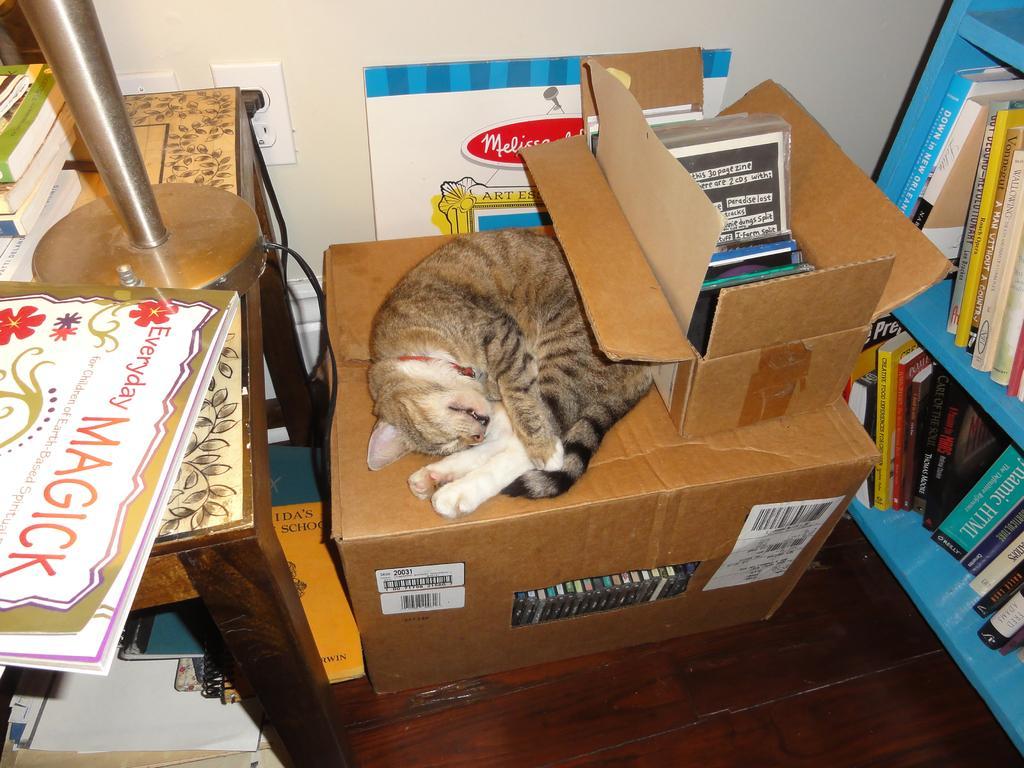Describe this image in one or two sentences. In this image there is a cat sleeping on the cardboard box. On the left side there is a table on which there are books and a metal stand. On the right side there are racks on which there are books. Beside the cat there is a box in which there are books. In the background there is a wall to which there is a switch board. 